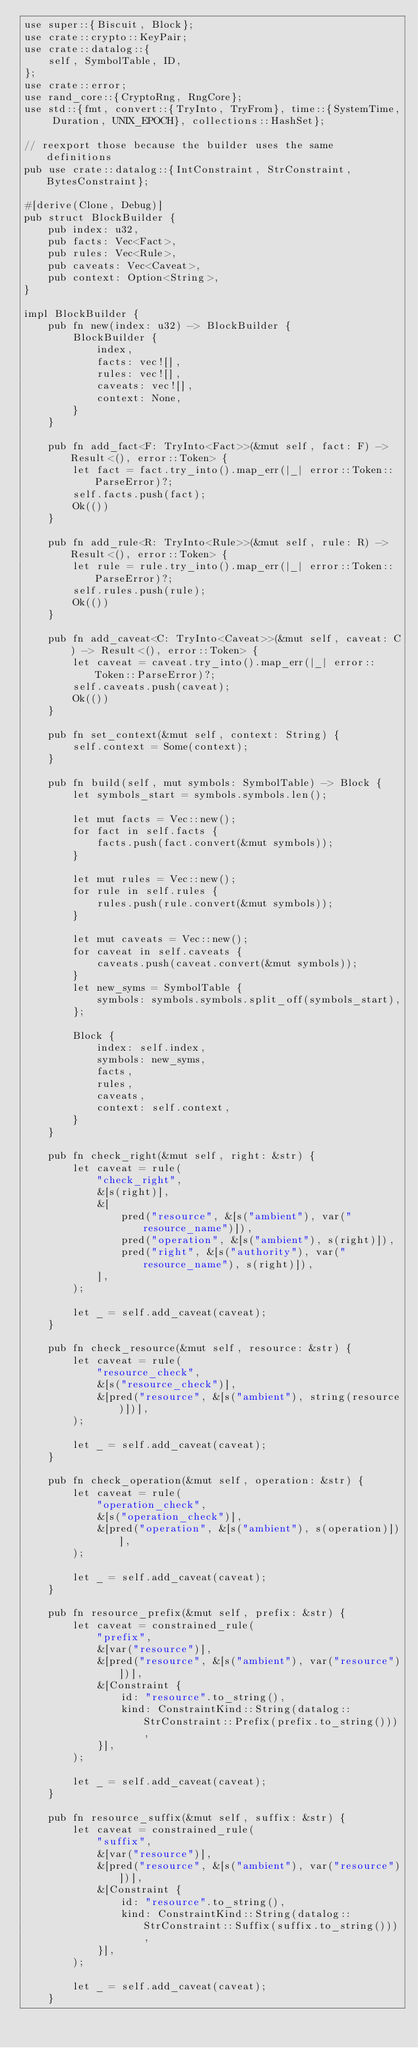<code> <loc_0><loc_0><loc_500><loc_500><_Rust_>use super::{Biscuit, Block};
use crate::crypto::KeyPair;
use crate::datalog::{
    self, SymbolTable, ID,
};
use crate::error;
use rand_core::{CryptoRng, RngCore};
use std::{fmt, convert::{TryInto, TryFrom}, time::{SystemTime, Duration, UNIX_EPOCH}, collections::HashSet};

// reexport those because the builder uses the same definitions
pub use crate::datalog::{IntConstraint, StrConstraint, BytesConstraint};

#[derive(Clone, Debug)]
pub struct BlockBuilder {
    pub index: u32,
    pub facts: Vec<Fact>,
    pub rules: Vec<Rule>,
    pub caveats: Vec<Caveat>,
    pub context: Option<String>,
}

impl BlockBuilder {
    pub fn new(index: u32) -> BlockBuilder {
        BlockBuilder {
            index,
            facts: vec![],
            rules: vec![],
            caveats: vec![],
            context: None,
        }
    }

    pub fn add_fact<F: TryInto<Fact>>(&mut self, fact: F) -> Result<(), error::Token> {
        let fact = fact.try_into().map_err(|_| error::Token::ParseError)?;
        self.facts.push(fact);
        Ok(())
    }

    pub fn add_rule<R: TryInto<Rule>>(&mut self, rule: R) -> Result<(), error::Token> {
        let rule = rule.try_into().map_err(|_| error::Token::ParseError)?;
        self.rules.push(rule);
        Ok(())
    }

    pub fn add_caveat<C: TryInto<Caveat>>(&mut self, caveat: C) -> Result<(), error::Token> {
        let caveat = caveat.try_into().map_err(|_| error::Token::ParseError)?;
        self.caveats.push(caveat);
        Ok(())
    }

    pub fn set_context(&mut self, context: String) {
        self.context = Some(context);
    }

    pub fn build(self, mut symbols: SymbolTable) -> Block {
        let symbols_start = symbols.symbols.len();

        let mut facts = Vec::new();
        for fact in self.facts {
            facts.push(fact.convert(&mut symbols));
        }

        let mut rules = Vec::new();
        for rule in self.rules {
            rules.push(rule.convert(&mut symbols));
        }

        let mut caveats = Vec::new();
        for caveat in self.caveats {
            caveats.push(caveat.convert(&mut symbols));
        }
        let new_syms = SymbolTable {
            symbols: symbols.symbols.split_off(symbols_start),
        };

        Block {
            index: self.index,
            symbols: new_syms,
            facts,
            rules,
            caveats,
            context: self.context,
        }
    }

    pub fn check_right(&mut self, right: &str) {
        let caveat = rule(
            "check_right",
            &[s(right)],
            &[
                pred("resource", &[s("ambient"), var("resource_name")]),
                pred("operation", &[s("ambient"), s(right)]),
                pred("right", &[s("authority"), var("resource_name"), s(right)]),
            ],
        );

        let _ = self.add_caveat(caveat);
    }

    pub fn check_resource(&mut self, resource: &str) {
        let caveat = rule(
            "resource_check",
            &[s("resource_check")],
            &[pred("resource", &[s("ambient"), string(resource)])],
        );

        let _ = self.add_caveat(caveat);
    }

    pub fn check_operation(&mut self, operation: &str) {
        let caveat = rule(
            "operation_check",
            &[s("operation_check")],
            &[pred("operation", &[s("ambient"), s(operation)])],
        );

        let _ = self.add_caveat(caveat);
    }

    pub fn resource_prefix(&mut self, prefix: &str) {
        let caveat = constrained_rule(
            "prefix",
            &[var("resource")],
            &[pred("resource", &[s("ambient"), var("resource")])],
            &[Constraint {
                id: "resource".to_string(),
                kind: ConstraintKind::String(datalog::StrConstraint::Prefix(prefix.to_string())),
            }],
        );

        let _ = self.add_caveat(caveat);
    }

    pub fn resource_suffix(&mut self, suffix: &str) {
        let caveat = constrained_rule(
            "suffix",
            &[var("resource")],
            &[pred("resource", &[s("ambient"), var("resource")])],
            &[Constraint {
                id: "resource".to_string(),
                kind: ConstraintKind::String(datalog::StrConstraint::Suffix(suffix.to_string())),
            }],
        );

        let _ = self.add_caveat(caveat);
    }
</code> 